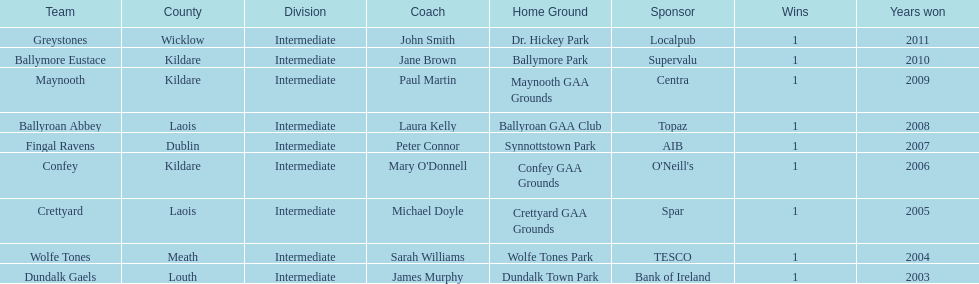What is the last team on the chart Dundalk Gaels. 